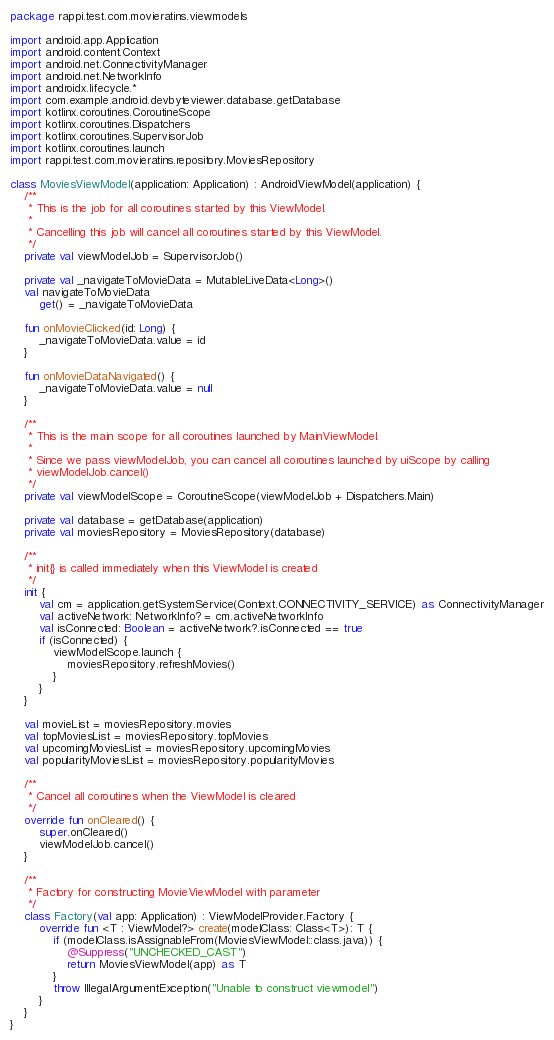Convert code to text. <code><loc_0><loc_0><loc_500><loc_500><_Kotlin_>package rappi.test.com.movieratins.viewmodels

import android.app.Application
import android.content.Context
import android.net.ConnectivityManager
import android.net.NetworkInfo
import androidx.lifecycle.*
import com.example.android.devbyteviewer.database.getDatabase
import kotlinx.coroutines.CoroutineScope
import kotlinx.coroutines.Dispatchers
import kotlinx.coroutines.SupervisorJob
import kotlinx.coroutines.launch
import rappi.test.com.movieratins.repository.MoviesRepository

class MoviesViewModel(application: Application) : AndroidViewModel(application) {
    /**
     * This is the job for all coroutines started by this ViewModel.
     *
     * Cancelling this job will cancel all coroutines started by this ViewModel.
     */
    private val viewModelJob = SupervisorJob()

    private val _navigateToMovieData = MutableLiveData<Long>()
    val navigateToMovieData
        get() = _navigateToMovieData

    fun onMovieClicked(id: Long) {
        _navigateToMovieData.value = id
    }

    fun onMovieDataNavigated() {
        _navigateToMovieData.value = null
    }

    /**
     * This is the main scope for all coroutines launched by MainViewModel.
     *
     * Since we pass viewModelJob, you can cancel all coroutines launched by uiScope by calling
     * viewModelJob.cancel()
     */
    private val viewModelScope = CoroutineScope(viewModelJob + Dispatchers.Main)

    private val database = getDatabase(application)
    private val moviesRepository = MoviesRepository(database)

    /**
     * init{} is called immediately when this ViewModel is created
     */
    init {
        val cm = application.getSystemService(Context.CONNECTIVITY_SERVICE) as ConnectivityManager
        val activeNetwork: NetworkInfo? = cm.activeNetworkInfo
        val isConnected: Boolean = activeNetwork?.isConnected == true
        if (isConnected) {
            viewModelScope.launch {
                moviesRepository.refreshMovies()
            }
        }
    }

    val movieList = moviesRepository.movies
    val topMoviesList = moviesRepository.topMovies
    val upcomingMoviesList = moviesRepository.upcomingMovies
    val popularityMoviesList = moviesRepository.popularityMovies

    /**
     * Cancel all coroutines when the ViewModel is cleared
     */
    override fun onCleared() {
        super.onCleared()
        viewModelJob.cancel()
    }

    /**
     * Factory for constructing MovieViewModel with parameter
     */
    class Factory(val app: Application) : ViewModelProvider.Factory {
        override fun <T : ViewModel?> create(modelClass: Class<T>): T {
            if (modelClass.isAssignableFrom(MoviesViewModel::class.java)) {
                @Suppress("UNCHECKED_CAST")
                return MoviesViewModel(app) as T
            }
            throw IllegalArgumentException("Unable to construct viewmodel")
        }
    }
}</code> 